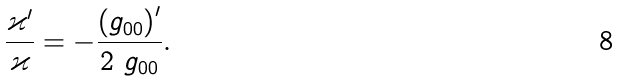<formula> <loc_0><loc_0><loc_500><loc_500>\frac { \varkappa ^ { \prime } } { \varkappa } = - \frac { \left ( g _ { 0 0 } \right ) ^ { \prime } } { 2 \ g _ { 0 0 } } .</formula> 